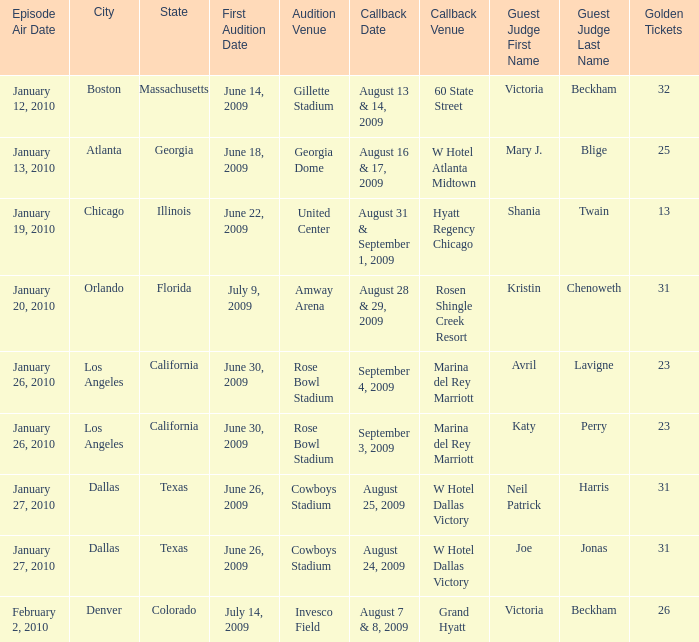Name the audition city for hyatt regency chicago Chicago, Illinois. 